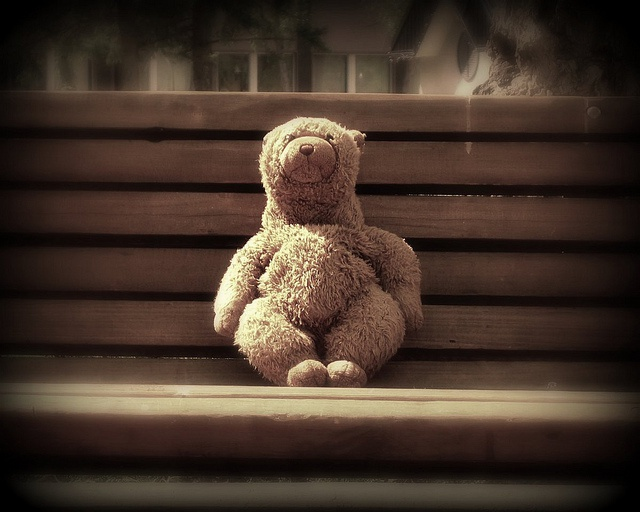Describe the objects in this image and their specific colors. I can see bench in black, maroon, and tan tones and teddy bear in black, maroon, brown, gray, and khaki tones in this image. 